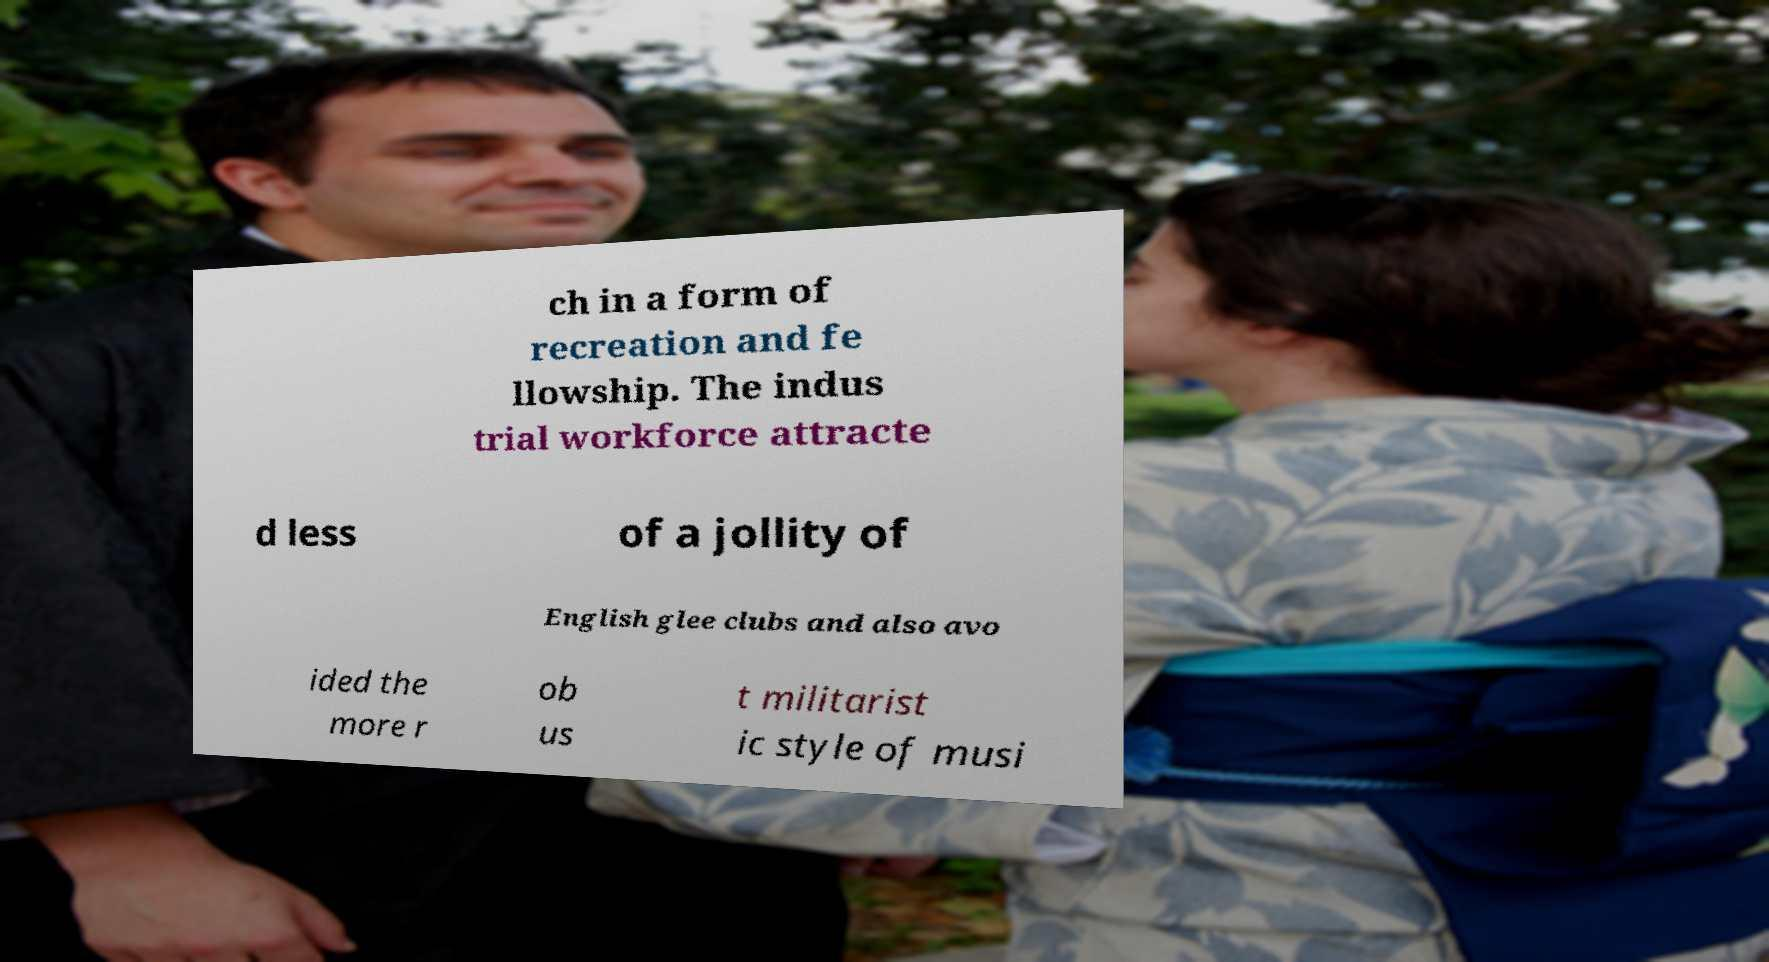Could you extract and type out the text from this image? ch in a form of recreation and fe llowship. The indus trial workforce attracte d less of a jollity of English glee clubs and also avo ided the more r ob us t militarist ic style of musi 